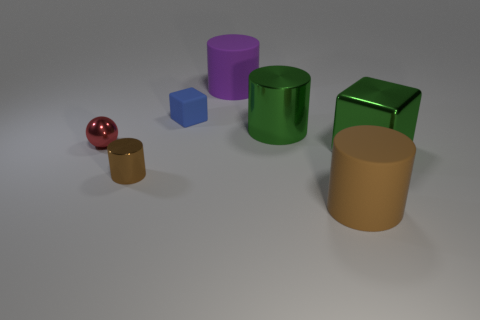Subtract all large metal cylinders. How many cylinders are left? 3 Subtract all cyan blocks. How many brown cylinders are left? 2 Subtract all purple cylinders. How many cylinders are left? 3 Subtract all gray cylinders. Subtract all cyan balls. How many cylinders are left? 4 Add 1 matte objects. How many objects exist? 8 Subtract all cubes. How many objects are left? 5 Subtract all small green matte balls. Subtract all big purple cylinders. How many objects are left? 6 Add 5 purple matte objects. How many purple matte objects are left? 6 Add 3 green shiny cylinders. How many green shiny cylinders exist? 4 Subtract 1 red spheres. How many objects are left? 6 